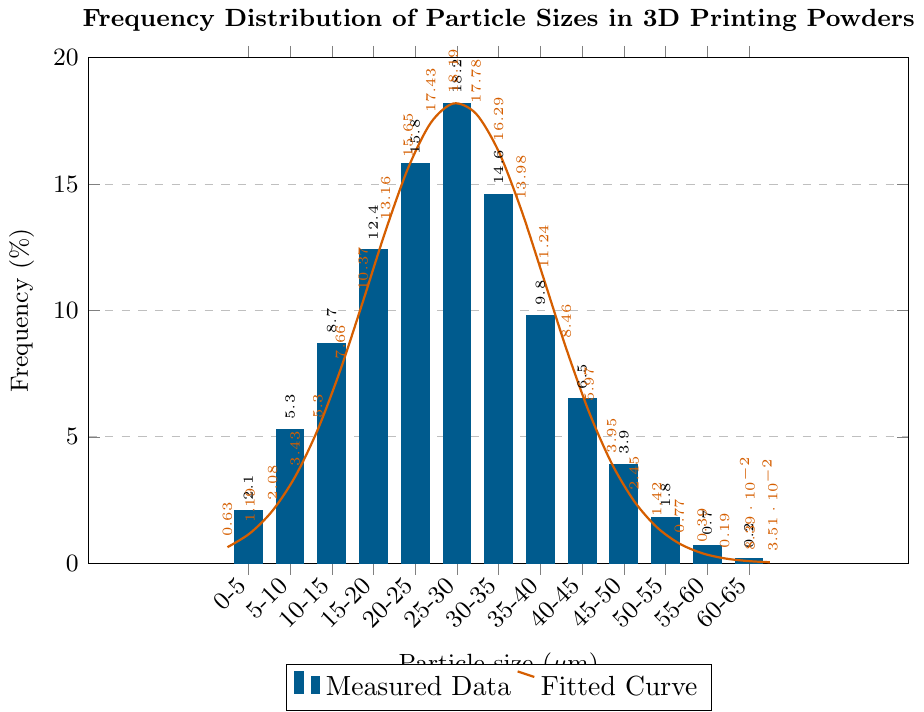What is the frequency percentage of particle sizes in the range of 25-30 μm? To determine the frequency percentage for the particle size range of 25-30 μm, locate the corresponding bar on the chart. The bar peaks at 18.2%.
Answer: 18.2% Between which particle size ranges does the frequency percentage drop below 5%? Look for bars where the frequency falls below 5%. The ranges with bars below 5% are: 0-5 μm, 45-50 μm, 50-55 μm, 55-60 μm, and 60-65 μm.
Answer: 0-5 μm, 45-50 μm, 50-55 μm, 55-60 μm, 60-65 μm Which particle size range has the highest frequency percentage and what is it? Identify the tallest bar on the chart. The tallest bar corresponds to the 25-30 μm range, with a frequency of 18.2%.
Answer: 25-30 μm, 18.2% Compare the frequency percentages of particle sizes 5-10 μm and 35-40 μm. Which is higher and by how much? The frequency for 5-10 μm is 5.3%, and for 35-40 μm, it is 9.8%. Subtract to find the difference: 9.8% - 5.3% = 4.5%.
Answer: 35-40 μm, 4.5% What is the combined frequency percentage of particle sizes in the ranges of 5-10 μm, 10-15 μm, and 15-20 μm? Add the frequencies: 5.3% (5-10 μm) + 8.7% (10-15 μm) + 12.4% (15-20 μm) = 26.4%.
Answer: 26.4% What are the characteristics of the red curve in the context of the chart? The red curve is a smooth, thick line representing a fitted model to the data points. It shows a peak near the highest measured frequency and describes how the data points are distributed around that peak.
Answer: Fitted model, peaks near highest frequency Which particle size range has the least frequency percentage and what is it? Identify the shortest bar on the chart. The shortest bar corresponds to the 60-65 μm range, with a frequency of 0.2%.
Answer: 60-65 μm, 0.2% Between which particle size ranges does the most rapid drop in frequency percentage occur? Observe the differences in heights between adjacent bars. The most rapid drop occurs between the 25-30 μm range (18.2%) and the 30-35 μm range (14.6%). The drop is 18.2% - 14.6% = 3.6%.
Answer: 25-30 μm and 30-35 μm How does the frequency of particle size 40-45 μm compare to that of 20-25 μm? The frequency for 40-45 μm is 6.5%, and for 20-25 μm, it is 15.8%. The 20-25 μm range has a significantly higher frequency.
Answer: 20-25 μm is higher Estimate the total frequency percentage represented by the particle sizes larger than 40 μm. Add the frequencies: 6.5% (40-45 μm) + 3.9% (45-50 μm) + 1.8% (50-55 μm) + 0.7% (55-60 μm) + 0.2% (60-65 μm) = 13.1%.
Answer: 13.1% 